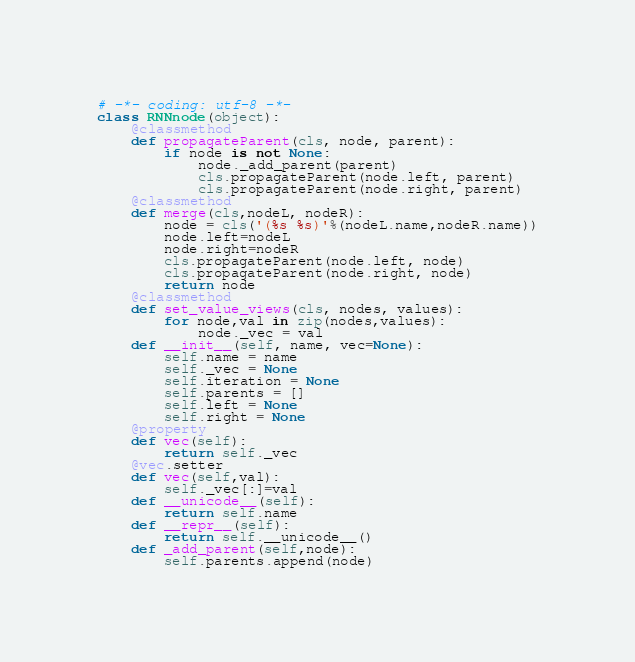<code> <loc_0><loc_0><loc_500><loc_500><_Python_># -*- coding: utf-8 -*-
class RNNnode(object):
    @classmethod
    def propagateParent(cls, node, parent):
        if node is not None:
            node._add_parent(parent)
            cls.propagateParent(node.left, parent)
            cls.propagateParent(node.right, parent)
    @classmethod
    def merge(cls,nodeL, nodeR):
        node = cls('(%s %s)'%(nodeL.name,nodeR.name))
        node.left=nodeL
        node.right=nodeR
        cls.propagateParent(node.left, node)
        cls.propagateParent(node.right, node)
        return node
    @classmethod
    def set_value_views(cls, nodes, values):
        for node,val in zip(nodes,values):
            node._vec = val
    def __init__(self, name, vec=None):
        self.name = name
        self._vec = None
        self.iteration = None
        self.parents = []
        self.left = None
        self.right = None
    @property
    def vec(self):
        return self._vec
    @vec.setter
    def vec(self,val):
        self._vec[:]=val
    def __unicode__(self):
        return self.name
    def __repr__(self):
        return self.__unicode__()
    def _add_parent(self,node):
        self.parents.append(node)
</code> 